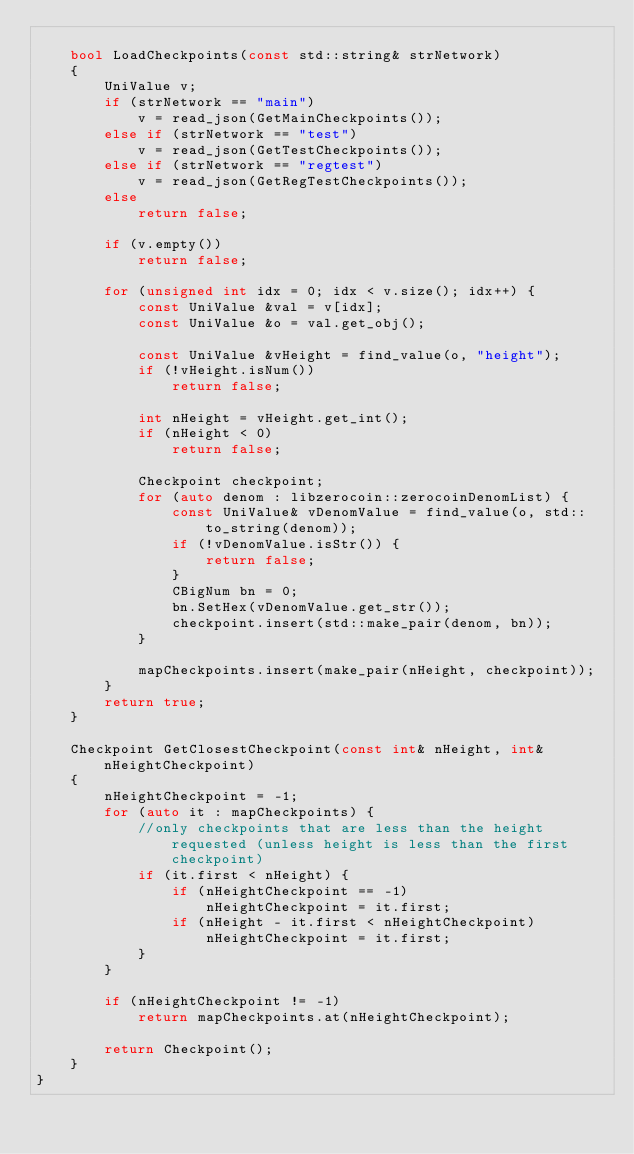<code> <loc_0><loc_0><loc_500><loc_500><_C++_>
    bool LoadCheckpoints(const std::string& strNetwork)
    {
        UniValue v;
        if (strNetwork == "main")
            v = read_json(GetMainCheckpoints());
        else if (strNetwork == "test")
            v = read_json(GetTestCheckpoints());
        else if (strNetwork == "regtest")
            v = read_json(GetRegTestCheckpoints());
        else
            return false;

        if (v.empty())
            return false;

        for (unsigned int idx = 0; idx < v.size(); idx++) {
            const UniValue &val = v[idx];
            const UniValue &o = val.get_obj();

            const UniValue &vHeight = find_value(o, "height");
            if (!vHeight.isNum())
                return false;

            int nHeight = vHeight.get_int();
            if (nHeight < 0)
                return false;

            Checkpoint checkpoint;
            for (auto denom : libzerocoin::zerocoinDenomList) {
                const UniValue& vDenomValue = find_value(o, std::to_string(denom));
                if (!vDenomValue.isStr()) {
                    return false;
                }
                CBigNum bn = 0;
                bn.SetHex(vDenomValue.get_str());
                checkpoint.insert(std::make_pair(denom, bn));
            }

            mapCheckpoints.insert(make_pair(nHeight, checkpoint));
        }
        return true;
    }

    Checkpoint GetClosestCheckpoint(const int& nHeight, int& nHeightCheckpoint)
    {
        nHeightCheckpoint = -1;
        for (auto it : mapCheckpoints) {
            //only checkpoints that are less than the height requested (unless height is less than the first checkpoint)
            if (it.first < nHeight) {
                if (nHeightCheckpoint == -1)
                    nHeightCheckpoint = it.first;
                if (nHeight - it.first < nHeightCheckpoint)
                    nHeightCheckpoint = it.first;
            }
        }

        if (nHeightCheckpoint != -1)
            return mapCheckpoints.at(nHeightCheckpoint);

        return Checkpoint();
    }
}

</code> 